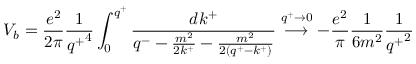Convert formula to latex. <formula><loc_0><loc_0><loc_500><loc_500>V _ { b } = \frac { e ^ { 2 } } { 2 \pi } \frac { 1 } { { q ^ { + } } ^ { 4 } } \int _ { 0 } ^ { q ^ { + } } \frac { d k ^ { + } } { q ^ { - } - \frac { m ^ { 2 } } { 2 k ^ { + } } - \frac { m ^ { 2 } } { 2 ( q ^ { + } - k ^ { + } ) } } \stackrel { q ^ { + } \rightarrow 0 } { \longrightarrow } - \frac { e ^ { 2 } } { \pi } \frac { 1 } { 6 m ^ { 2 } } \frac { 1 } { { q ^ { + } } ^ { 2 } }</formula> 